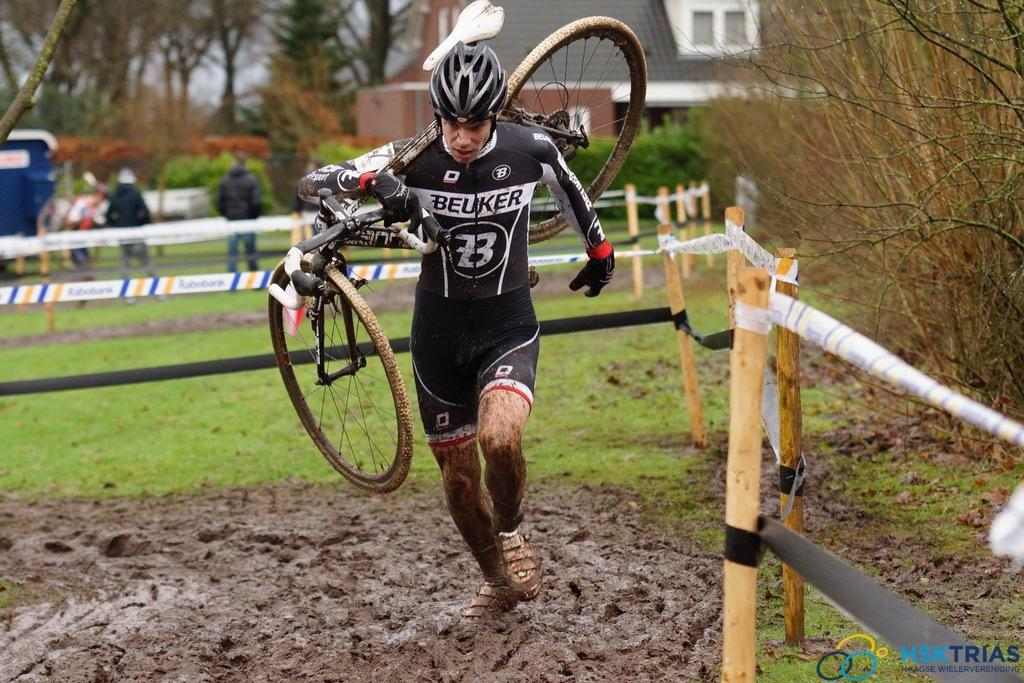<image>
Describe the image concisely. The man with the Beuker shirt on is carrying his bike through the mud. 